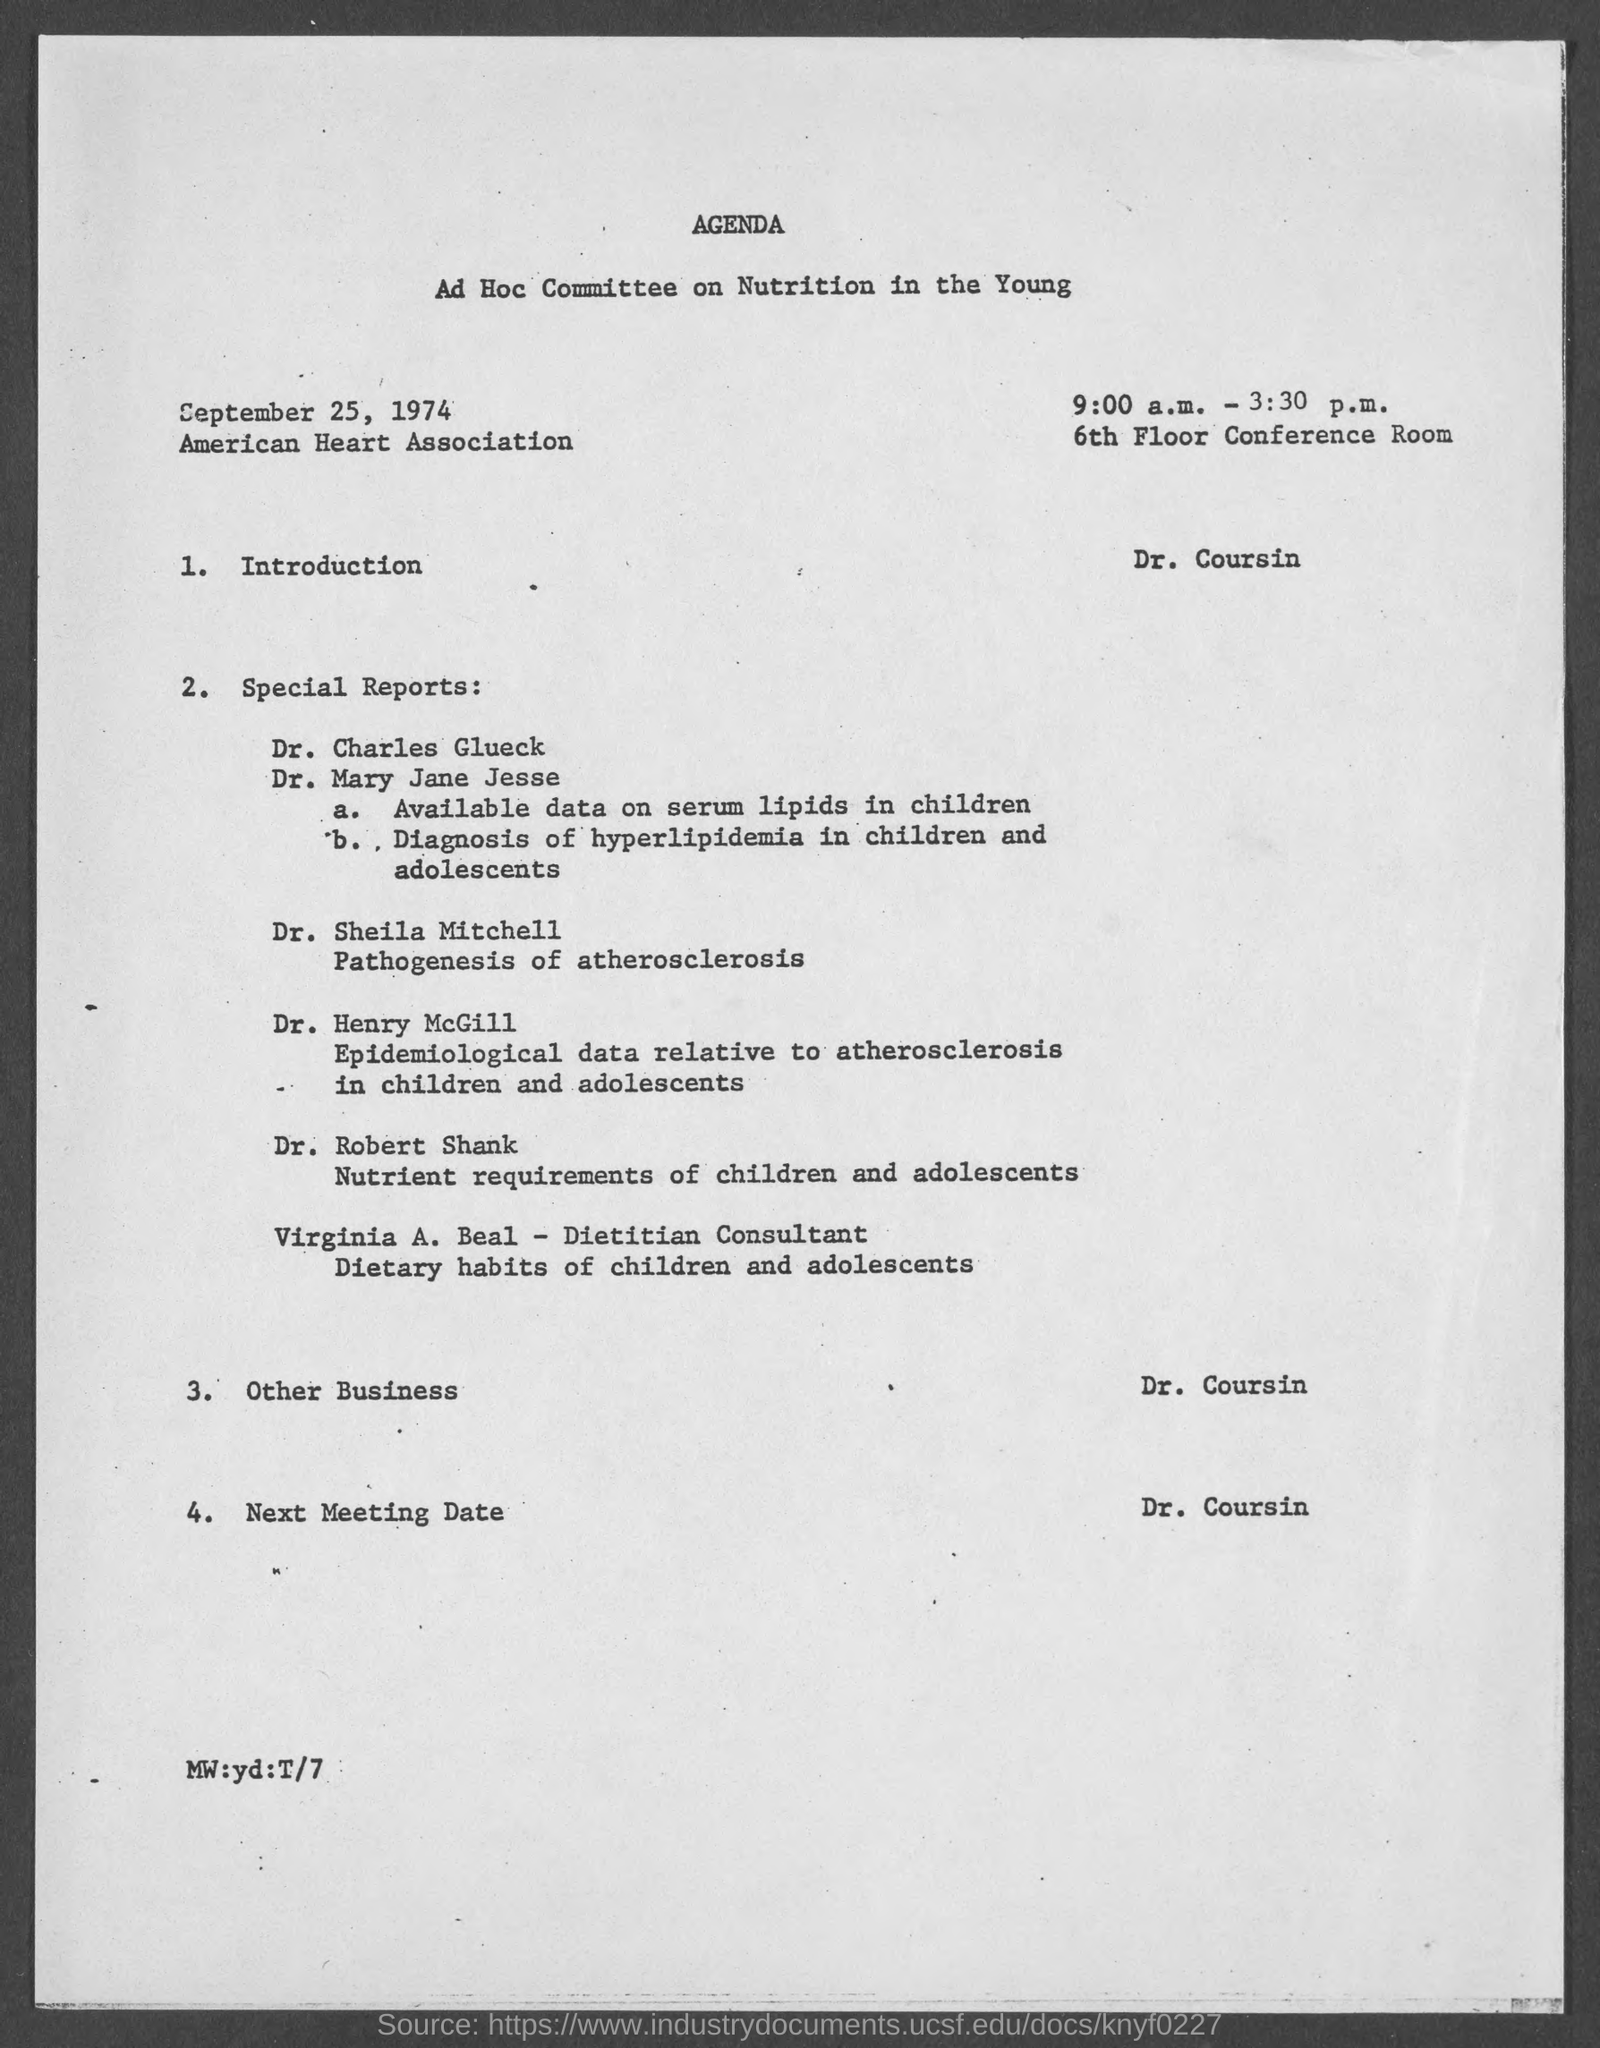Mention a couple of crucial points in this snapshot. The Ad Hoc Committee on Nutrition in the Young will take place from 9:00 a.m. to 3:30 p.m. The Ad Hoc Committee on Nutrition in the Young is located in the 6th Floor Conference Room. The speaker declared that Dr. Coursin was giving the introduction. The Ad Hoc Committee on Nutrition in the Young met on September 25, 1974. 